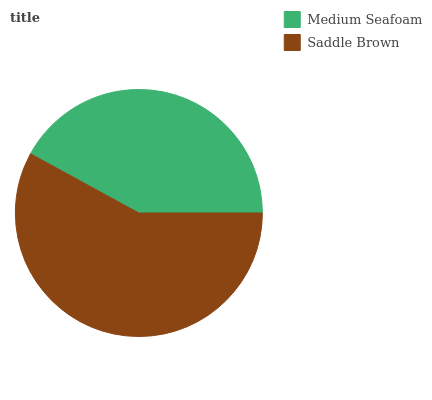Is Medium Seafoam the minimum?
Answer yes or no. Yes. Is Saddle Brown the maximum?
Answer yes or no. Yes. Is Saddle Brown the minimum?
Answer yes or no. No. Is Saddle Brown greater than Medium Seafoam?
Answer yes or no. Yes. Is Medium Seafoam less than Saddle Brown?
Answer yes or no. Yes. Is Medium Seafoam greater than Saddle Brown?
Answer yes or no. No. Is Saddle Brown less than Medium Seafoam?
Answer yes or no. No. Is Saddle Brown the high median?
Answer yes or no. Yes. Is Medium Seafoam the low median?
Answer yes or no. Yes. Is Medium Seafoam the high median?
Answer yes or no. No. Is Saddle Brown the low median?
Answer yes or no. No. 